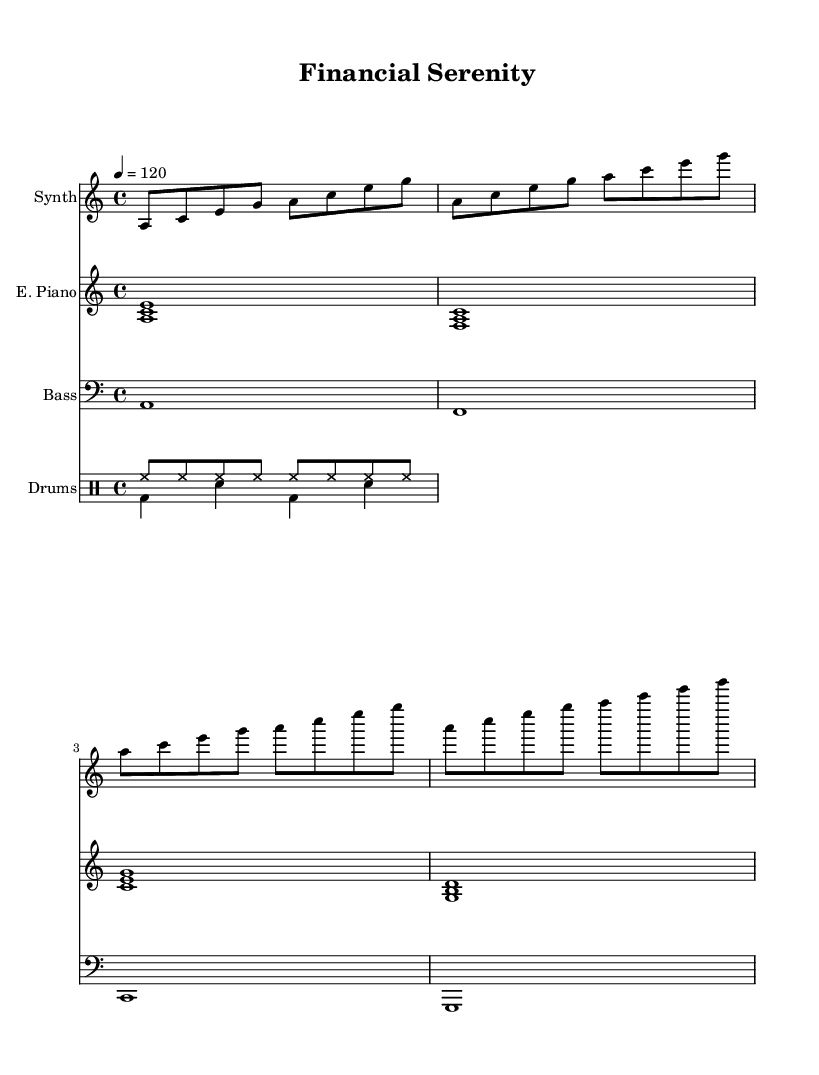What is the key signature of this music? The key signature is A minor, which has no sharps or flats listed on the staff. This is indicated by the initial key signature sign on the left side of the staff.
Answer: A minor What is the time signature of this music? The time signature is found at the beginning of the staff, indicated by the "4/4" marking. This means there are four beats in each measure and a quarter note receives one beat.
Answer: 4/4 What is the tempo marking of this piece? The tempo marking is indicated as "4 = 120," meaning the piece is played at a speed of 120 beats per minute. This is usually found in the header or near the top of the score.
Answer: 120 How many measures does the melody consist of? There are four measures shown in the melody section of the music. Each measure is separated by vertical lines, and counting these gives us the total.
Answer: 4 What instruments are used in this score? The score includes a synth, electric piano, bass, and drums. Each is clearly labeled at the beginning of each staff, indicating the different instruments being played.
Answer: Synth, electric piano, bass, drums What type of drum pattern is used in this piece? The drum pattern includes a hi-hat and bass drum, which are common elements in house music. The specific notation shows consistent hi-hats and alternating bass drums, typical of deep house.
Answer: Hi-hat, bass drum What is the first chord played by the electric piano? The first chord played by the electric piano is an A minor chord (A, C, E), indicated by the notation of the three notes played simultaneously at the beginning of the electric piano staff.
Answer: A minor 